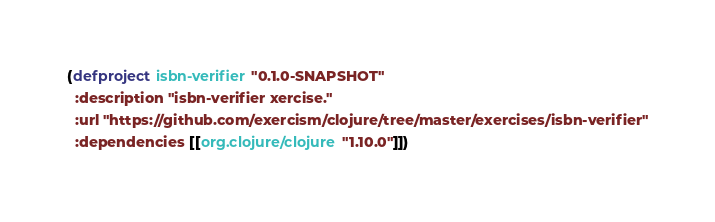Convert code to text. <code><loc_0><loc_0><loc_500><loc_500><_Clojure_>(defproject isbn-verifier "0.1.0-SNAPSHOT"
  :description "isbn-verifier xercise."
  :url "https://github.com/exercism/clojure/tree/master/exercises/isbn-verifier"
  :dependencies [[org.clojure/clojure "1.10.0"]])
</code> 